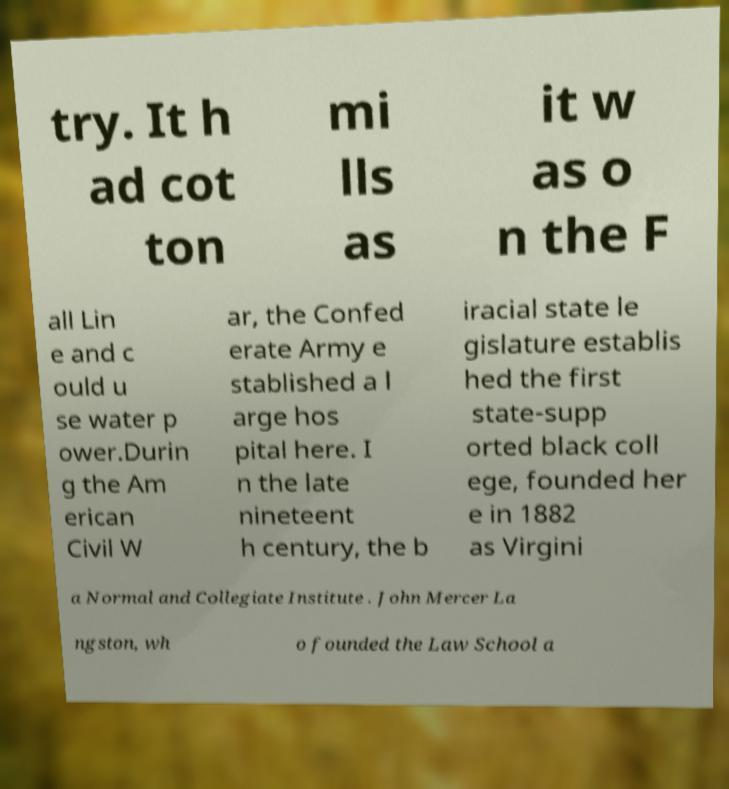For documentation purposes, I need the text within this image transcribed. Could you provide that? try. It h ad cot ton mi lls as it w as o n the F all Lin e and c ould u se water p ower.Durin g the Am erican Civil W ar, the Confed erate Army e stablished a l arge hos pital here. I n the late nineteent h century, the b iracial state le gislature establis hed the first state-supp orted black coll ege, founded her e in 1882 as Virgini a Normal and Collegiate Institute . John Mercer La ngston, wh o founded the Law School a 